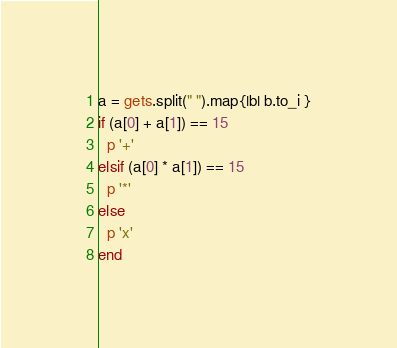<code> <loc_0><loc_0><loc_500><loc_500><_Ruby_>a = gets.split(" ").map{|b| b.to_i }
if (a[0] + a[1]) == 15
  p '+'
elsif (a[0] * a[1]) == 15
  p '*'
else
  p 'x'
end</code> 